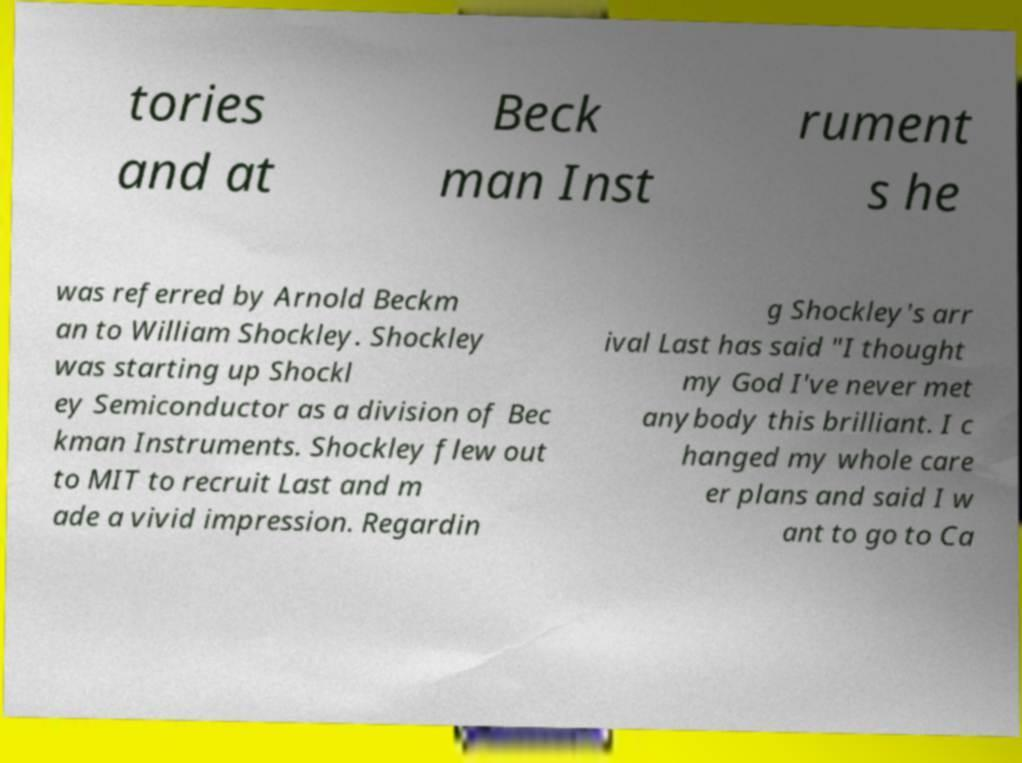Can you read and provide the text displayed in the image?This photo seems to have some interesting text. Can you extract and type it out for me? tories and at Beck man Inst rument s he was referred by Arnold Beckm an to William Shockley. Shockley was starting up Shockl ey Semiconductor as a division of Bec kman Instruments. Shockley flew out to MIT to recruit Last and m ade a vivid impression. Regardin g Shockley's arr ival Last has said "I thought my God I've never met anybody this brilliant. I c hanged my whole care er plans and said I w ant to go to Ca 